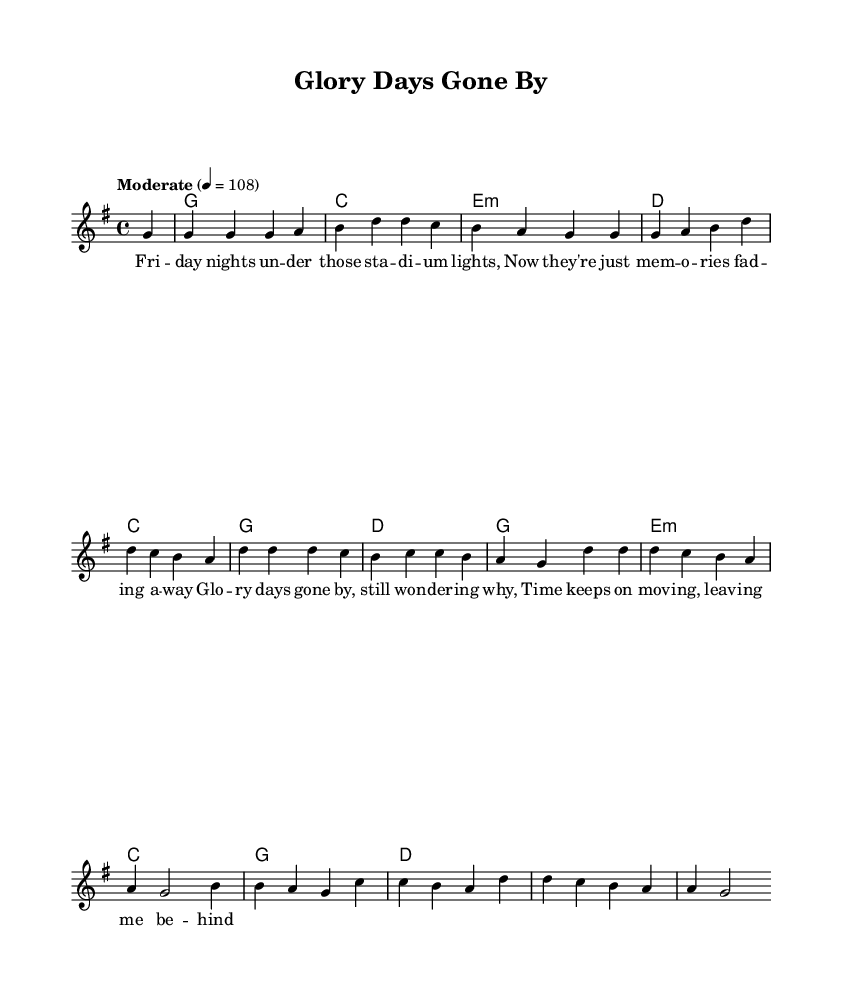What is the key signature of this music? The key signature is G major, which has one sharp (F#). This can be identified at the beginning of the sheet music where the key signature is displayed.
Answer: G major What is the time signature of this music? The time signature is 4/4, signifying four beats per measure. This is presented at the beginning of the sheet music, indicating how the music is measured.
Answer: 4/4 What is the tempo marking for the piece? The tempo marking is "Moderate" with a metronome marking of 108, indicating the desired speed for the performance. This information is shown near the beginning of the score.
Answer: Moderate How many measures are in the melody section? The melody section consists of 10 measures, which can be counted by examining the melody line and identifying the bar lines separating each measure.
Answer: 10 What is the first lyric line of the song? The first lyric line is "Friday nights under those stadium lights," identified by examining the lyrics placed beneath the notes in the melody section.
Answer: Friday nights under those stadium lights Which chords are used in the first measure? The chords used in the first measure are G major. This can be determined by looking at the chord symbols above the staff in the first measure of the harmony section.
Answer: G What is the overall theme of the lyrics based on the title and context? The overall theme relates to nostalgia and reflection on past experiences after sports, as suggested by the title "Glory Days Gone By" and the emotional content of the lyrics. This context is derived from the title and lyrical content.
Answer: Nostalgia 